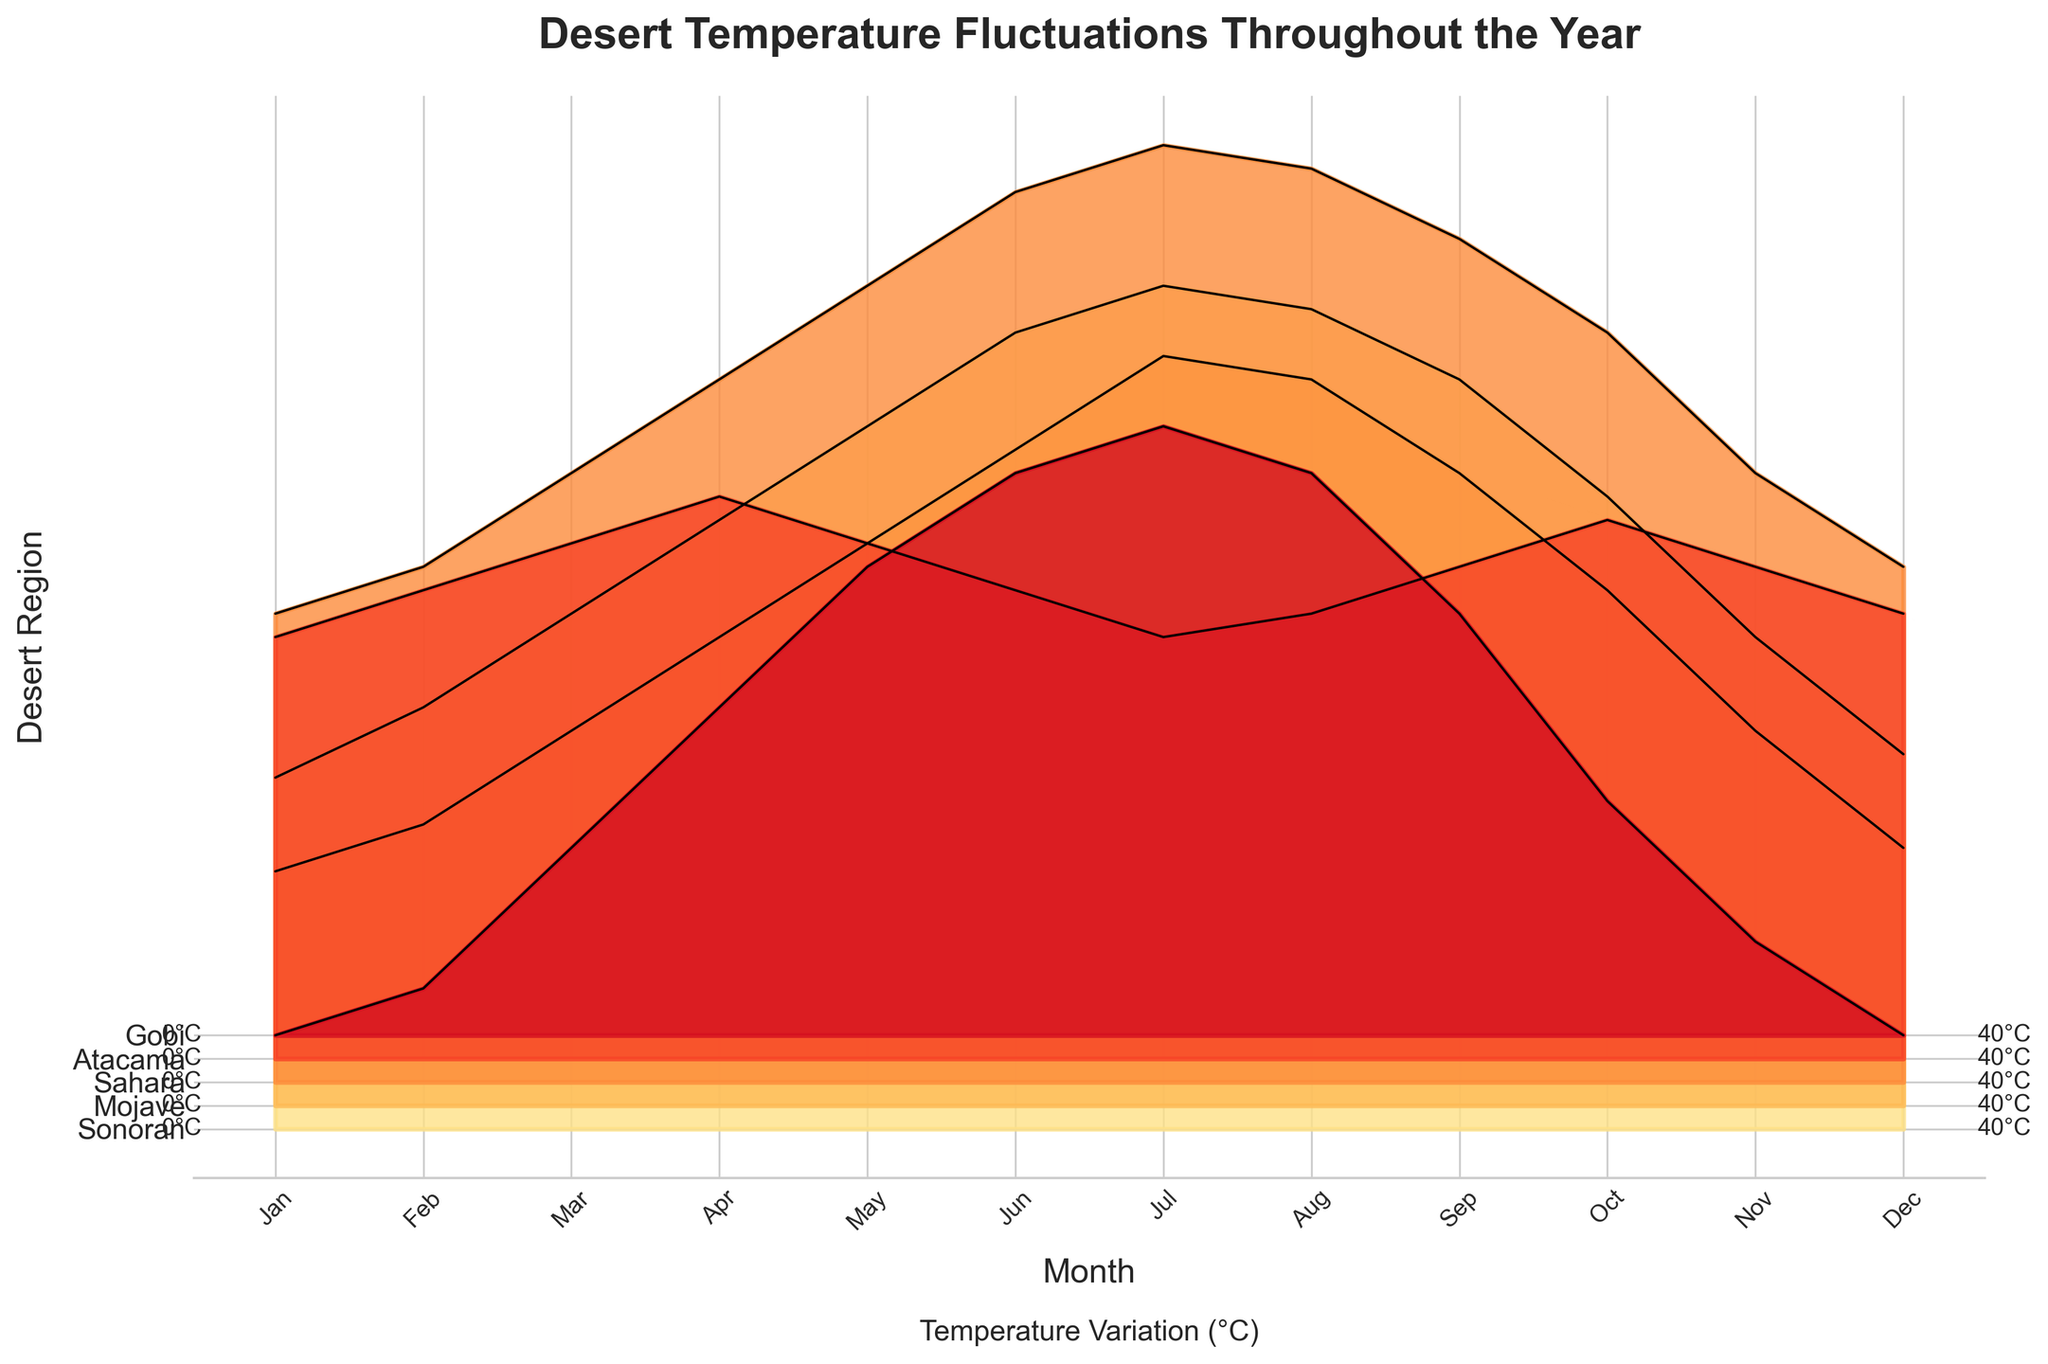Which desert region has the highest temperature in July? To find this, look at the data on the ridgeline plot for July, and identify the highest peak. The highest ridge in July corresponds to the Sahara.
Answer: Sahara In December, which desert has the lowest temperature? Locate the December data points in the ridgeline plot, and identify the lowest peak. The lowest ridge in December belongs to both the Sonoran and Gobi deserts.
Answer: Sonoran and Gobi What is the average temperature in the Atacama desert for the months of June, July, and August? Extract the temperature values for Atacama in June (20), July (18), and August (19) from the plot. Sum these values: 20 + 18 + 19 = 57. Divide by the number of months (3) to get the average: 57/3 = 19.
Answer: 19 Which desert region shows the greatest temperature fluctuation over the year? Observe the ridgeline plot and compare the highest and lowest points for each desert throughout the year. The Sahara has the greatest temperature fluctuation with the highest peak at 40°C and the lowest at 20°C, giving a fluctuation of 20°C.
Answer: Sahara In which month do all deserts have their highest temperatures? By examining the plot, it is clear that most desert regions reach their peak in July.
Answer: July During which month does the temperature in the Gobi desert rise above 10°C for the first time in the year? Identify the Gobi temperature ridgeline data and see when it first crosses above 10°C. This occurs in March.
Answer: March Are there any months where the Mojave desert temperature is higher than the Sonoran desert temperature? Compare the ridgelines of the Sonoran and Mojave deserts month by month. The Mojave desert never has a higher temperature than the Sonoran desert throughout the year.
Answer: No Which desert shows the least variation in temperature throughout the year? Analyze the ridgelines for each desert to see which one has the smallest range between its highest and lowest temperatures. The Gobi desert shows the least variation in temperature.
Answer: Gobi How does the temperature change in the Sonoran desert from April to May? Examine the ridgeline plot for the Sonoran desert from April to May. The temperature increases from 26°C to 30°C, a rise of 4°C.
Answer: Increase by 4°C 